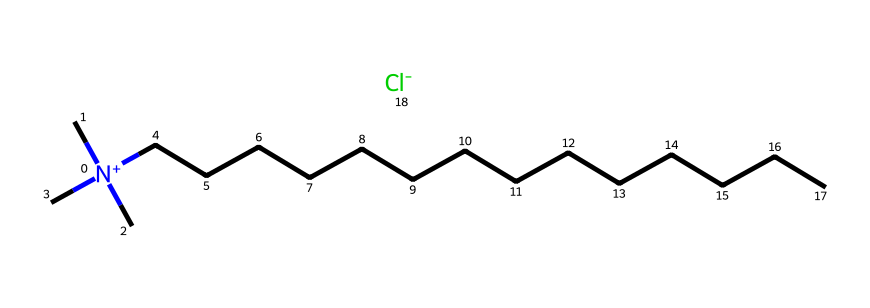What kind of ion is present in this compound? The SMILES representation shows a positively charged nitrogen atom followed by a chloride ion, indicated by [Cl-]. The presence of Cl- denotes that it is an anion.
Answer: chloride How many carbon atoms are in the carbon chain? By analyzing the SMILES, the carbon chain "CCCCCCCCCCCCCC" indicates there are 14 carbon atoms (each "C" represents one carbon atom).
Answer: 14 What type of chemical is this compound? The presence of a quaternary ammonium group, characterized by the positively charged nitrogen attached to four carbon chains, indicates that this compound is a quaternary ammonium compound.
Answer: quaternary ammonium compound What is the charge of the nitrogen atom in this compound? The nitrogen is represented with [N+] in the SMILES notation, indicating that it has a positive charge.
Answer: positive What role does the long carbon chain play in the activity of this compound? The long carbon chain enhances the hydrophobic nature of the compound, improving its ability to interact with oils and greases, which is essential for detergency and sanitization.
Answer: detergency 